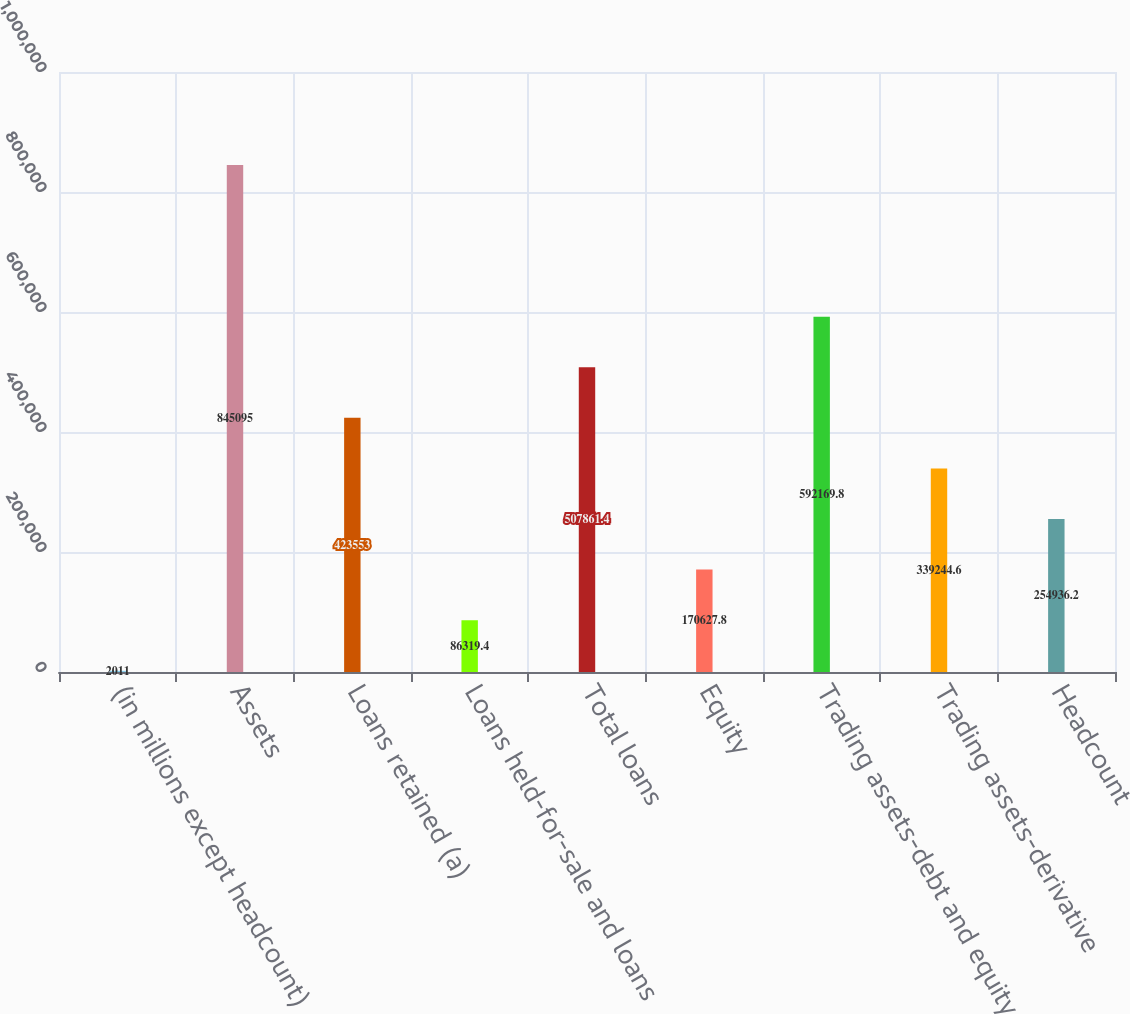Convert chart to OTSL. <chart><loc_0><loc_0><loc_500><loc_500><bar_chart><fcel>(in millions except headcount)<fcel>Assets<fcel>Loans retained (a)<fcel>Loans held-for-sale and loans<fcel>Total loans<fcel>Equity<fcel>Trading assets-debt and equity<fcel>Trading assets-derivative<fcel>Headcount<nl><fcel>2011<fcel>845095<fcel>423553<fcel>86319.4<fcel>507861<fcel>170628<fcel>592170<fcel>339245<fcel>254936<nl></chart> 